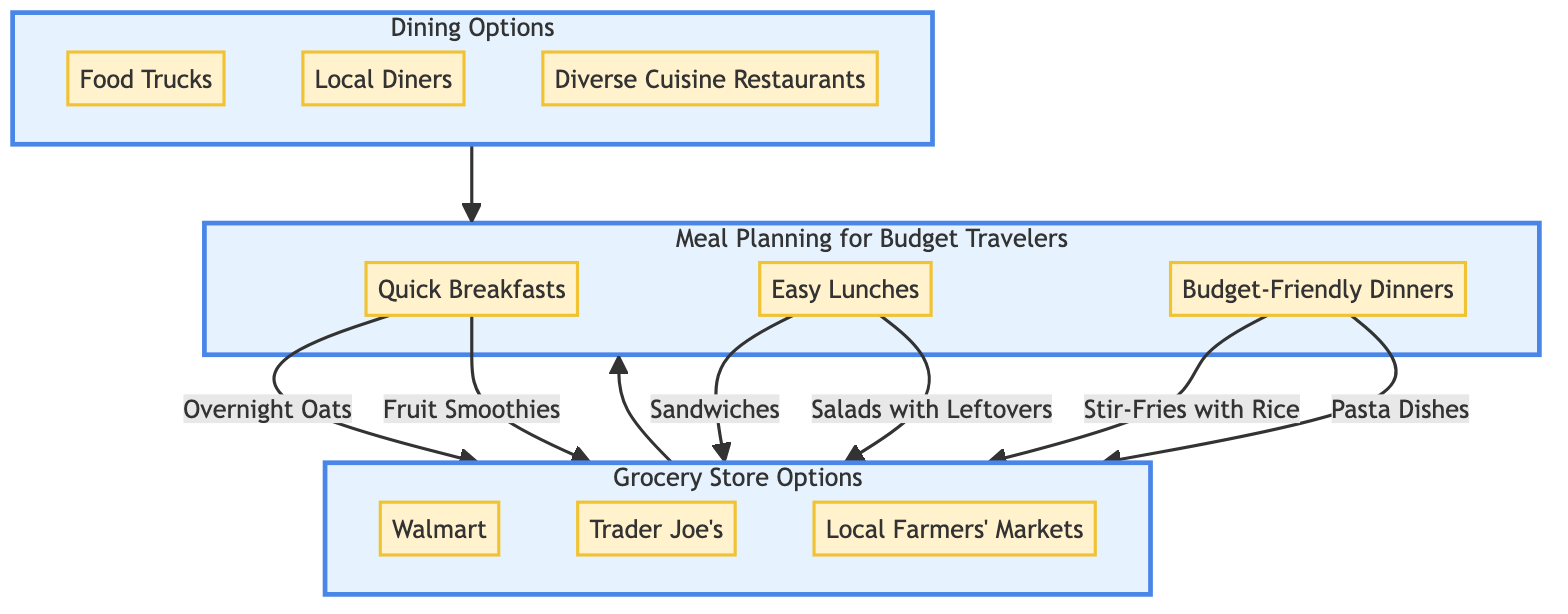What are the available breakfast options in Meal Prep Ideas? To find the breakfast options, I look at the Meal Prep Ideas section of the diagram. The available breakfast options listed are "Overnight Oats" and "Fruit Smoothies".
Answer: Overnight Oats, Fruit Smoothies How many grocery store options are presented in the diagram? By counting the items listed under Grocery Store Options, there are three options: Walmart, Trader Joe's, and Local Farmers' Markets.
Answer: 3 Which dining option includes Tacos? I locate "Tacos" under the Food Trucks category in the Dining Options section.
Answer: Food Trucks What type of meals can be prepared for Budget-Friendly Dinners? Looking under Meal Prep Ideas, I find that the options for Budget-Friendly Dinners are "Stir-Fries with Rice" and "Pasta Dishes".
Answer: Stir-Fries with Rice, Pasta Dishes What is the relationship between Grocery Store Options and Meal Prep Ideas? The flow from Grocery Store Options leads into Meal Prep Ideas, indicating that the grocery options feed into meal preparations, suggesting that ingredients from grocery stores are utilized in meal planning.
Answer: Feed into What are the unique snacks available at Trader Joe's? Under Trader Joe's in the Grocery Store Options section, the unique snacks listed are "Unique International Snacks" and "Organic Options".
Answer: Unique International Snacks, Organic Options What is the total number of dining options mentioned in the diagram? Counting the dining options listed, there are three: Food Trucks, Local Diners, and Diverse Cuisine Restaurants.
Answer: 3 Which meal prep idea is categorized under Easy Lunches? The Easy Lunches category contains "Sandwiches" and "Salads with Leftovers" as options for this meal type.
Answer: Sandwiches, Salads with Leftovers Which grocery store option provides Affordable Fresh Produce? Affordable Fresh Produce is found under Walmart in the Grocery Store Options section.
Answer: Walmart 